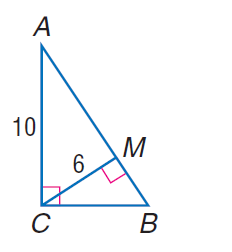Answer the mathemtical geometry problem and directly provide the correct option letter.
Question: Find the perimeter of \triangle A B C.
Choices: A: 20 B: 24 C: 30 D: 32 C 